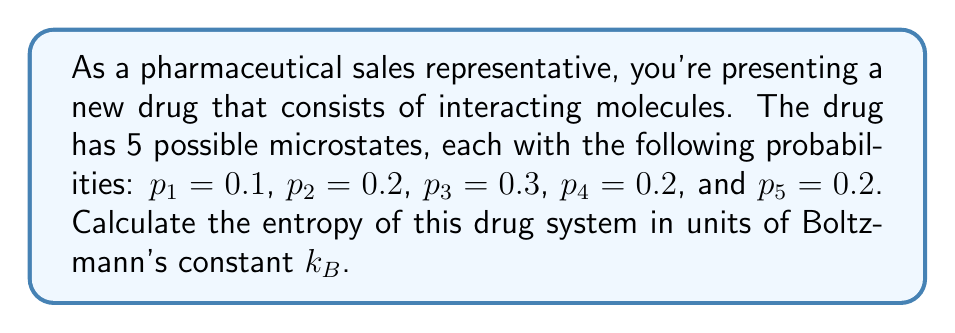Could you help me with this problem? To determine the entropy of the system, we'll use the Gibbs entropy formula:

$$S = -k_B \sum_{i} p_i \ln(p_i)$$

Where $S$ is the entropy, $k_B$ is Boltzmann's constant, and $p_i$ are the probabilities of each microstate.

Let's calculate each term:

1) $-p_1 \ln(p_1) = -0.1 \ln(0.1) = 0.2303$
2) $-p_2 \ln(p_2) = -0.2 \ln(0.2) = 0.3219$
3) $-p_3 \ln(p_3) = -0.3 \ln(0.3) = 0.3612$
4) $-p_4 \ln(p_4) = -0.2 \ln(0.2) = 0.3219$
5) $-p_5 \ln(p_5) = -0.2 \ln(0.2) = 0.3219$

Now, sum all these terms:

$$\sum_{i} -p_i \ln(p_i) = 0.2303 + 0.3219 + 0.3612 + 0.3219 + 0.3219 = 1.5572$$

Therefore, the entropy is:

$$S = k_B \cdot 1.5572 = 1.5572k_B$$
Answer: $1.5572k_B$ 